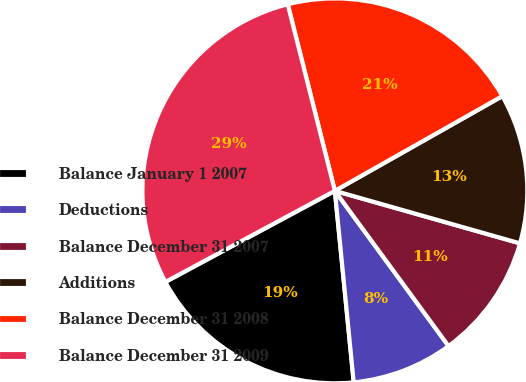Convert chart to OTSL. <chart><loc_0><loc_0><loc_500><loc_500><pie_chart><fcel>Balance January 1 2007<fcel>Deductions<fcel>Balance December 31 2007<fcel>Additions<fcel>Balance December 31 2008<fcel>Balance December 31 2009<nl><fcel>18.71%<fcel>8.5%<fcel>10.54%<fcel>12.59%<fcel>20.75%<fcel>28.91%<nl></chart> 